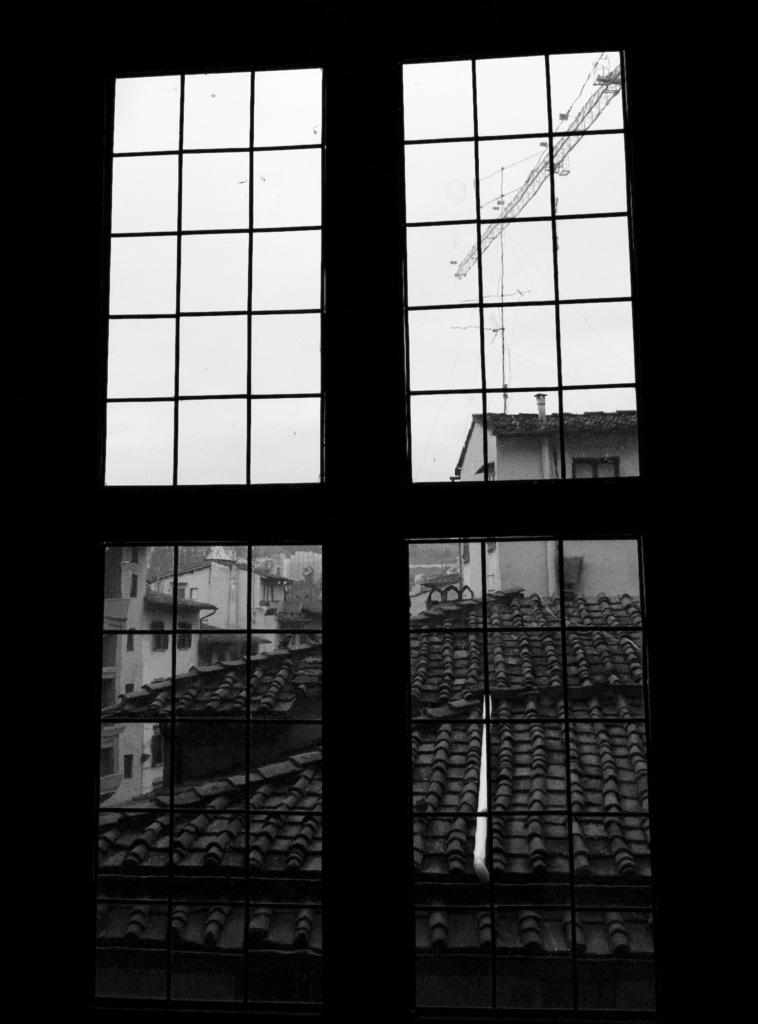What is located in the foreground of the image? There is a window in the foreground of the image. What can be seen through the window? Houses and the sky are visible through the window. What is the object at the top of the image? There appears to be a crane at the top of the image. What type of arm is visible in the image? There is no arm visible in the image. Can you spot a plane in the image? There is no plane present in the image. 